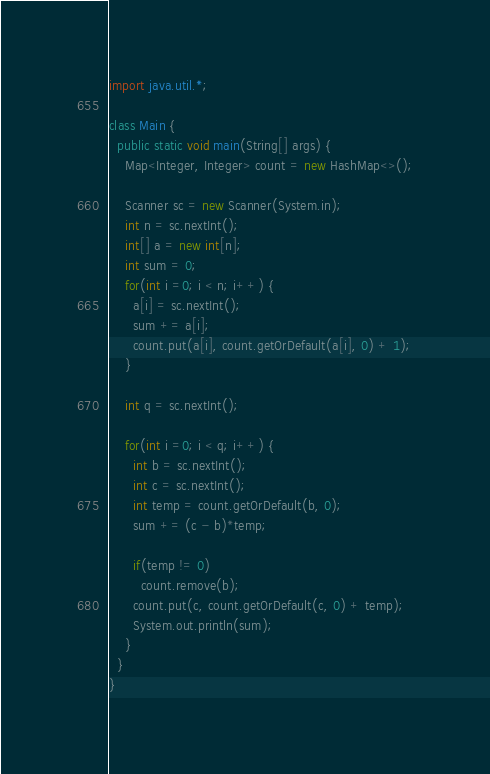Convert code to text. <code><loc_0><loc_0><loc_500><loc_500><_Java_>import java.util.*;

class Main {
  public static void main(String[] args) {
    Map<Integer, Integer> count = new HashMap<>();
    
    Scanner sc = new Scanner(System.in);
    int n = sc.nextInt();
    int[] a = new int[n];
    int sum = 0;
    for(int i =0; i < n; i++) {
      a[i] = sc.nextInt();
      sum += a[i];
      count.put(a[i], count.getOrDefault(a[i], 0) + 1);
    }
    
    int q = sc.nextInt();
    
    for(int i =0; i < q; i++) {
      int b = sc.nextInt();
      int c = sc.nextInt();
      int temp = count.getOrDefault(b, 0);
      sum += (c - b)*temp;

      if(temp != 0)
        count.remove(b);
      count.put(c, count.getOrDefault(c, 0) + temp);
      System.out.println(sum);
    }
  }
}</code> 